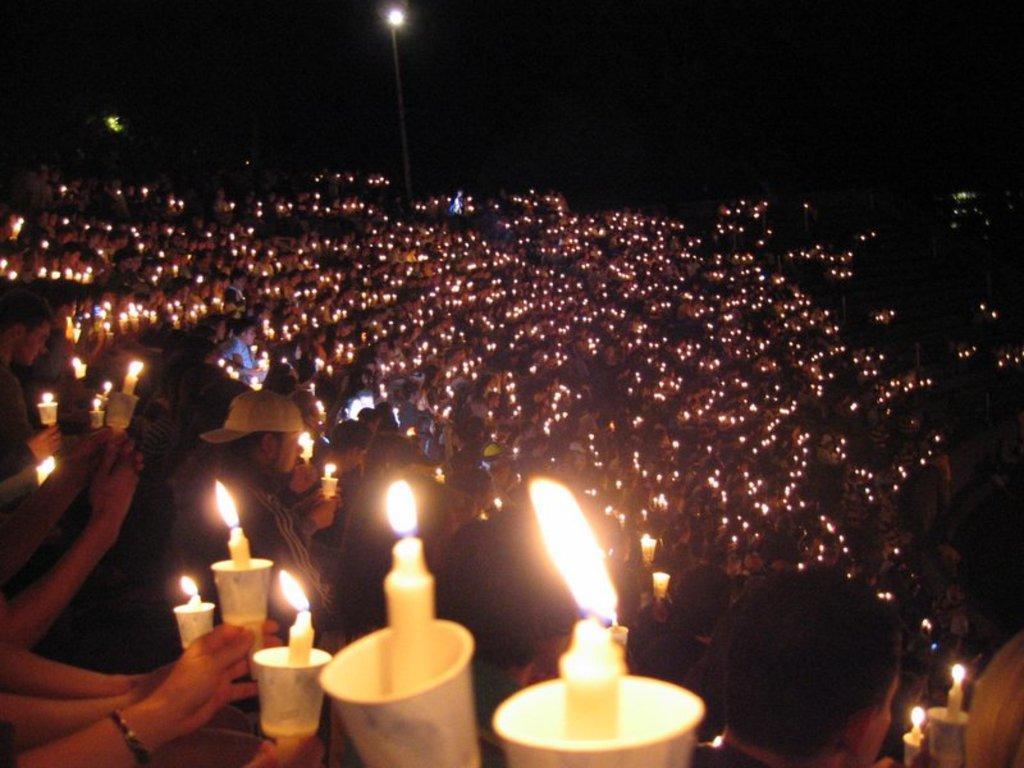Can you describe this image briefly? In this image we can see a few people, some of them are holding cups, and candles, also we can see the light pole, the background is dark. 